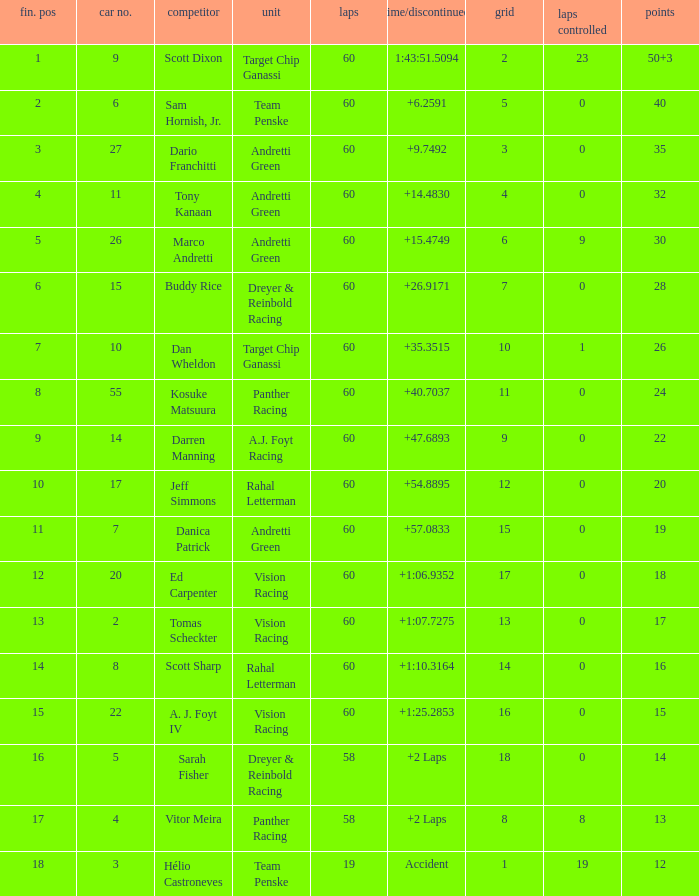Name the laps for 18 pointss 60.0. Help me parse the entirety of this table. {'header': ['fin. pos', 'car no.', 'competitor', 'unit', 'laps', 'time/discontinued', 'grid', 'laps controlled', 'points'], 'rows': [['1', '9', 'Scott Dixon', 'Target Chip Ganassi', '60', '1:43:51.5094', '2', '23', '50+3'], ['2', '6', 'Sam Hornish, Jr.', 'Team Penske', '60', '+6.2591', '5', '0', '40'], ['3', '27', 'Dario Franchitti', 'Andretti Green', '60', '+9.7492', '3', '0', '35'], ['4', '11', 'Tony Kanaan', 'Andretti Green', '60', '+14.4830', '4', '0', '32'], ['5', '26', 'Marco Andretti', 'Andretti Green', '60', '+15.4749', '6', '9', '30'], ['6', '15', 'Buddy Rice', 'Dreyer & Reinbold Racing', '60', '+26.9171', '7', '0', '28'], ['7', '10', 'Dan Wheldon', 'Target Chip Ganassi', '60', '+35.3515', '10', '1', '26'], ['8', '55', 'Kosuke Matsuura', 'Panther Racing', '60', '+40.7037', '11', '0', '24'], ['9', '14', 'Darren Manning', 'A.J. Foyt Racing', '60', '+47.6893', '9', '0', '22'], ['10', '17', 'Jeff Simmons', 'Rahal Letterman', '60', '+54.8895', '12', '0', '20'], ['11', '7', 'Danica Patrick', 'Andretti Green', '60', '+57.0833', '15', '0', '19'], ['12', '20', 'Ed Carpenter', 'Vision Racing', '60', '+1:06.9352', '17', '0', '18'], ['13', '2', 'Tomas Scheckter', 'Vision Racing', '60', '+1:07.7275', '13', '0', '17'], ['14', '8', 'Scott Sharp', 'Rahal Letterman', '60', '+1:10.3164', '14', '0', '16'], ['15', '22', 'A. J. Foyt IV', 'Vision Racing', '60', '+1:25.2853', '16', '0', '15'], ['16', '5', 'Sarah Fisher', 'Dreyer & Reinbold Racing', '58', '+2 Laps', '18', '0', '14'], ['17', '4', 'Vitor Meira', 'Panther Racing', '58', '+2 Laps', '8', '8', '13'], ['18', '3', 'Hélio Castroneves', 'Team Penske', '19', 'Accident', '1', '19', '12']]} 